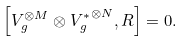<formula> <loc_0><loc_0><loc_500><loc_500>\left [ V _ { g } ^ { \otimes M } \otimes { V _ { g } ^ { * } } ^ { \otimes N } , R \right ] = 0 .</formula> 